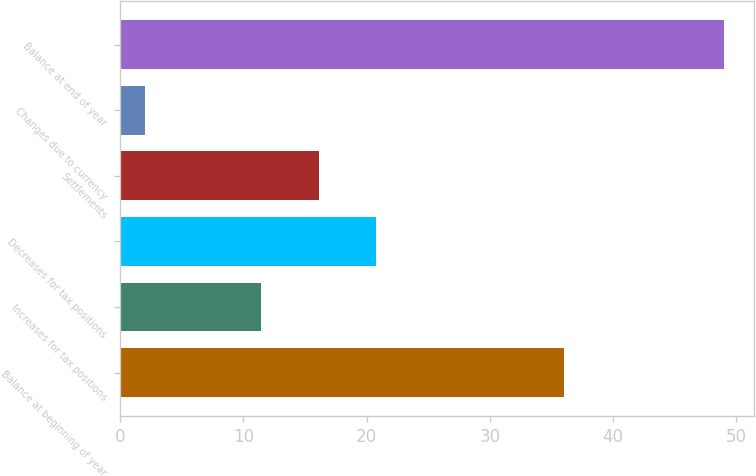Convert chart. <chart><loc_0><loc_0><loc_500><loc_500><bar_chart><fcel>Balance at beginning of year<fcel>Increases for tax positions<fcel>Decreases for tax positions<fcel>Settlements<fcel>Changes due to currency<fcel>Balance at end of year<nl><fcel>36<fcel>11.4<fcel>20.8<fcel>16.1<fcel>2<fcel>49<nl></chart> 